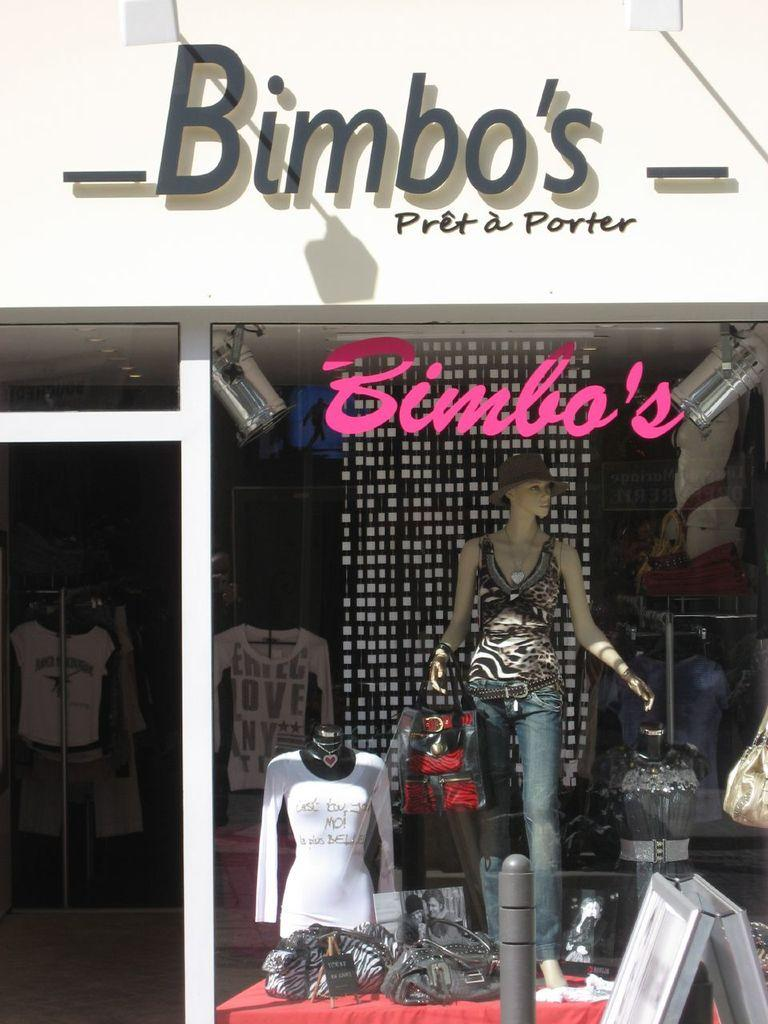<image>
Write a terse but informative summary of the picture. A mannequin wearing stylish clothes in the window of Bimbo's Pret a Porter. 